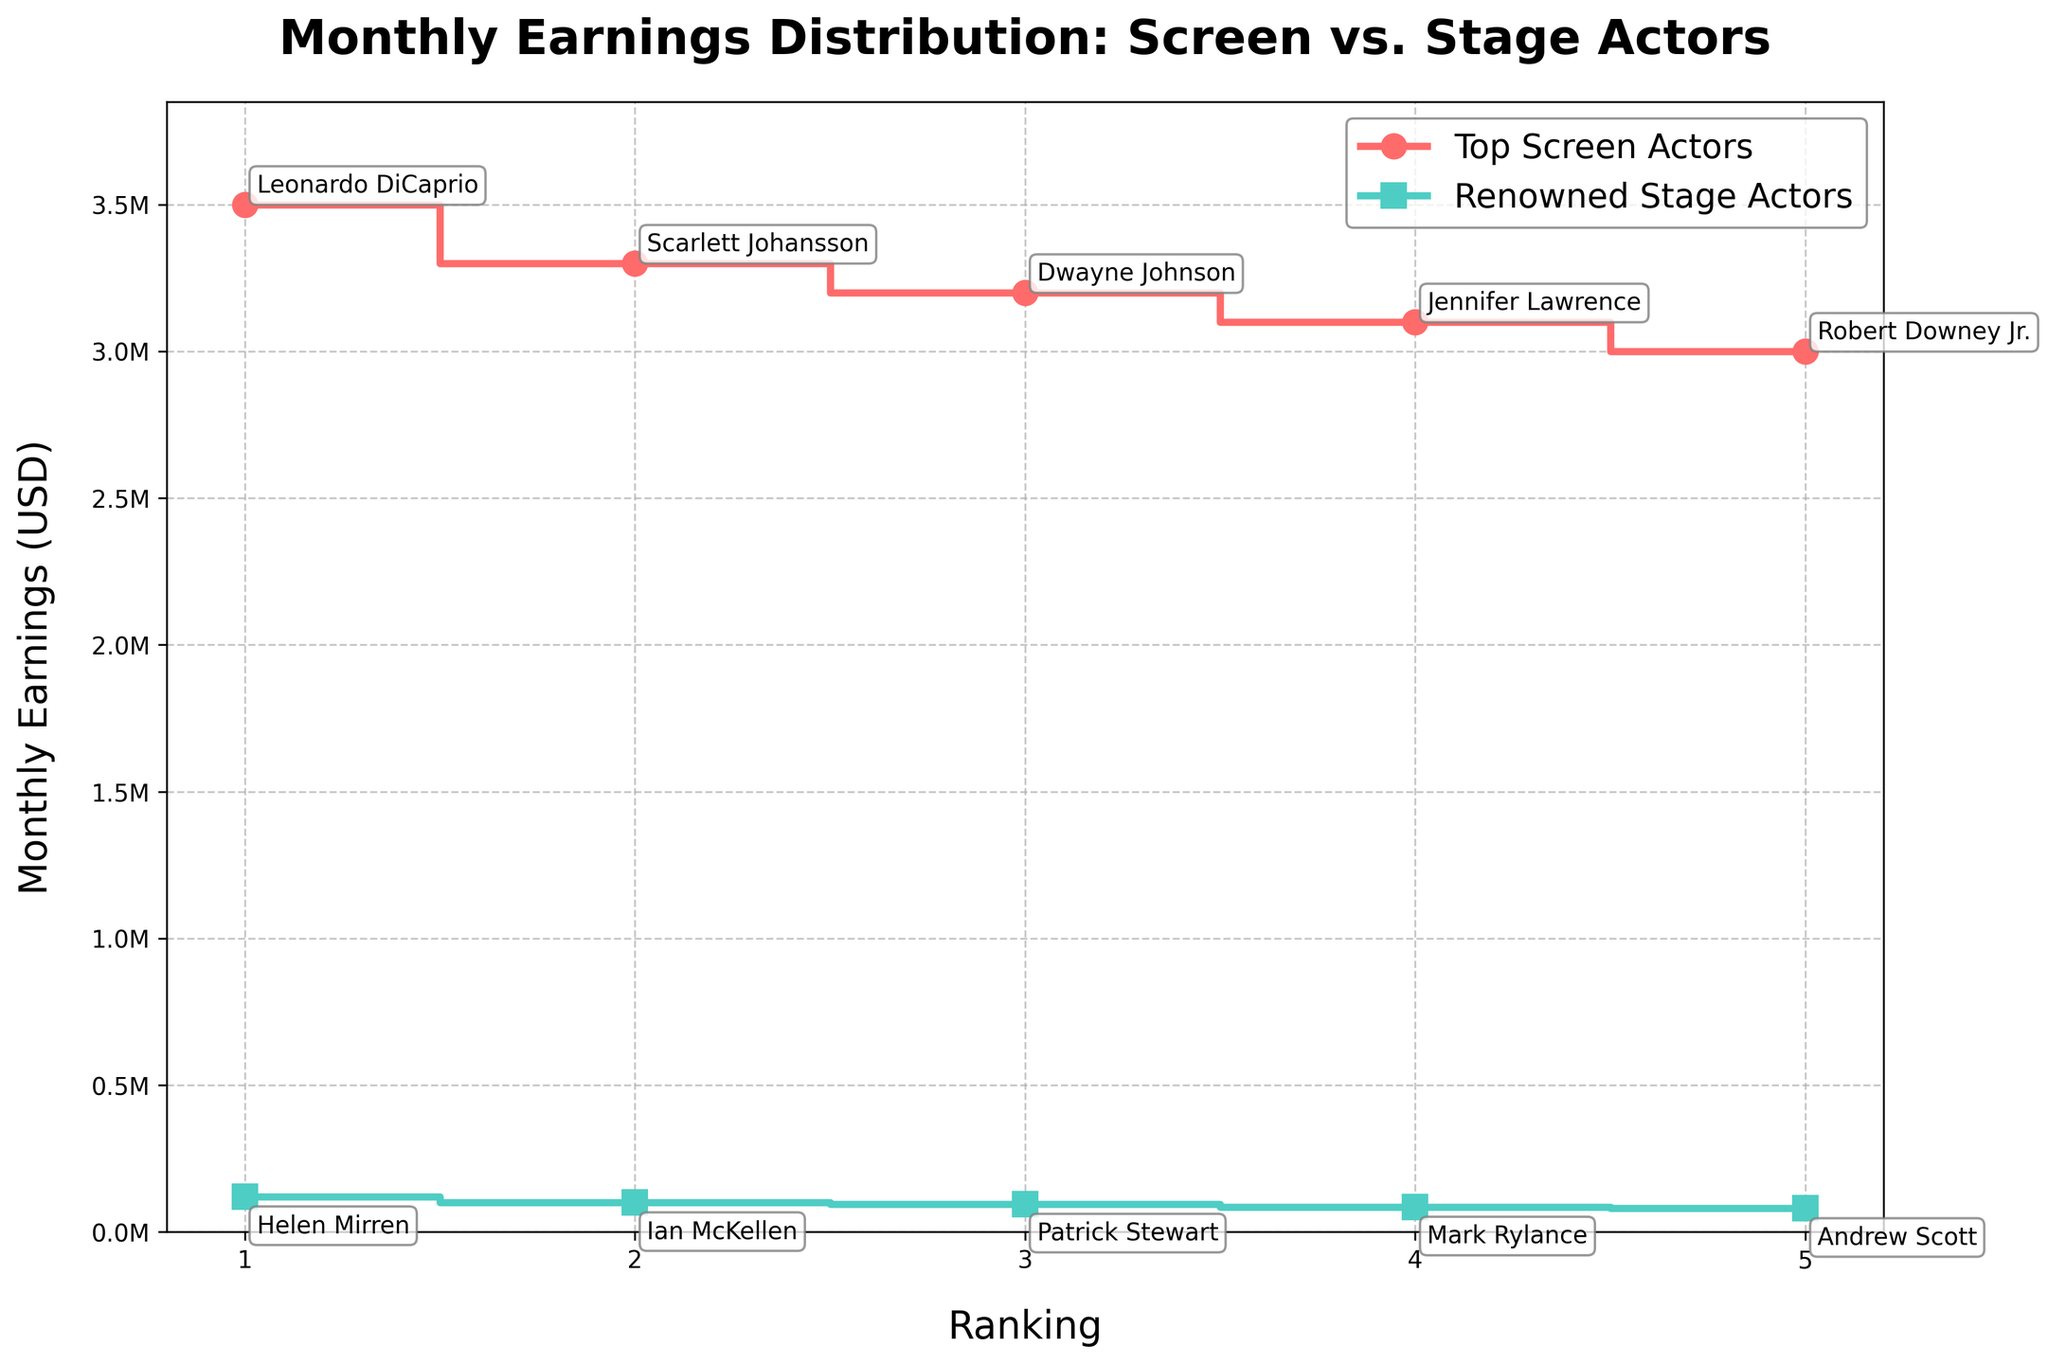What is the title of the plot? The title is typically located at the top of the chart. In this case, it reads: "Monthly Earnings Distribution: Screen vs. Stage Actors."
Answer: Monthly Earnings Distribution: Screen vs. Stage Actors What y-axis measurement is used for the earnings? The y-axis is labeled "Monthly Earnings (USD)," and the values are formatted in millions with 'M' to denote million dollars.
Answer: Monthly Earnings (USD) How many top screen actors are displayed in the plot? We can count the number of steps (or data points) labeled for "Top Screen Actors" on the plot. There are 5 such data points.
Answer: 5 Which actor earns the most among the top screen actors, and what is their earning? By looking at the first step in the red line for "Top Screen Actors," we see Leonardo DiCaprio at the highest earning, which is 3.5 million USD.
Answer: Leonardo DiCaprio, 3.5 million USD What is the total monthly earning of the renowned stage actors combined? Add the monthly earnings of each renowned stage actor: 100,000 + 95,000 + 120,000 + 85,000 + 80,000 = 480,000 USD.
Answer: 480,000 USD What is the difference in monthly earnings between the highest-earning screen actor and the highest-earning stage actor? The highest-earning screen actor is Leonardo DiCaprio at 3.5 million USD, and the highest-earning stage actor is Helen Mirren at 120,000 USD. The difference is 3,500,000 - 120,000 = 3,380,000 USD.
Answer: 3,380,000 USD Among the screen actors and stage actors, which category has a wider range of monthly earnings? Range is calculated as the difference between the highest and lowest earnings. For screen actors, 3,500,000 - 3,000,000 = 500,000 USD. For stage actors, 120,000 - 80,000 = 40,000 USD. Screen actors have a wider range of earnings.
Answer: Screen actors Which actor has the lowest monthly earning among the renowned stage actors, and what is it? In the plot, the last step of the green line for "Renowned Stage Actors" shows Andrew Scott with the lowest earning, which is 80,000 USD.
Answer: Andrew Scott, 80,000 USD What is the visual difference in the plot for the annotations of screen actors compared to stage actors? Screen actor names are annotated above the data points with boxes having round, padded edges, while stage actor names are annotated below their data points with similar annotation styles.
Answer: Screen: above points, Stage: below points 